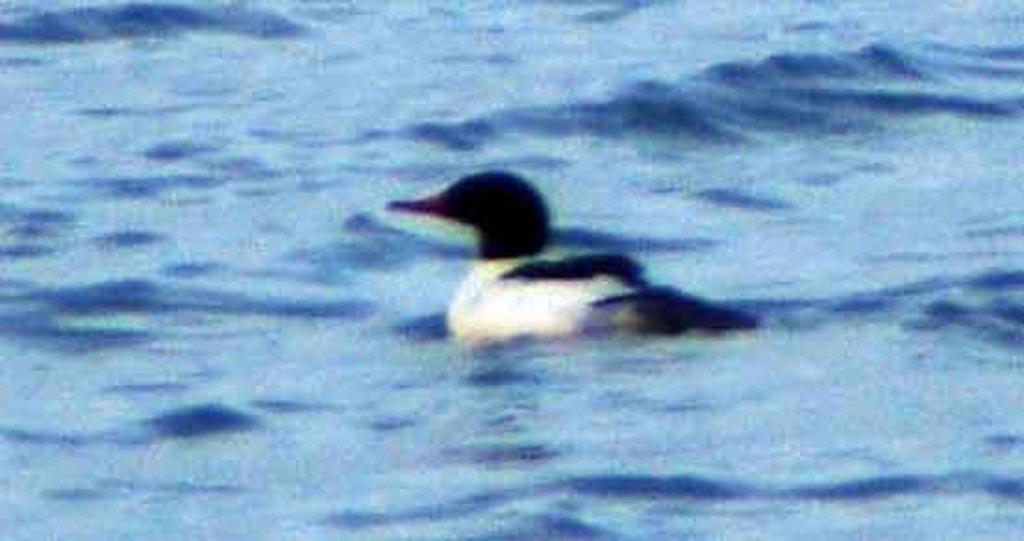What is the main subject in the image? The main subject in the image is a duct. What can be said about the color of the duct? The duct is black and white in color. Where is the duct located in the image? The duct is present in the water. What time is displayed on the hour in the image? There is no hour or clock present in the image, so it is not possible to determine the time. Are there any dinosaurs visible in the image? There are no dinosaurs present in the image. What type of property is shown in the image? There is no property or real estate depicted in the image; it features a duct in the water. 